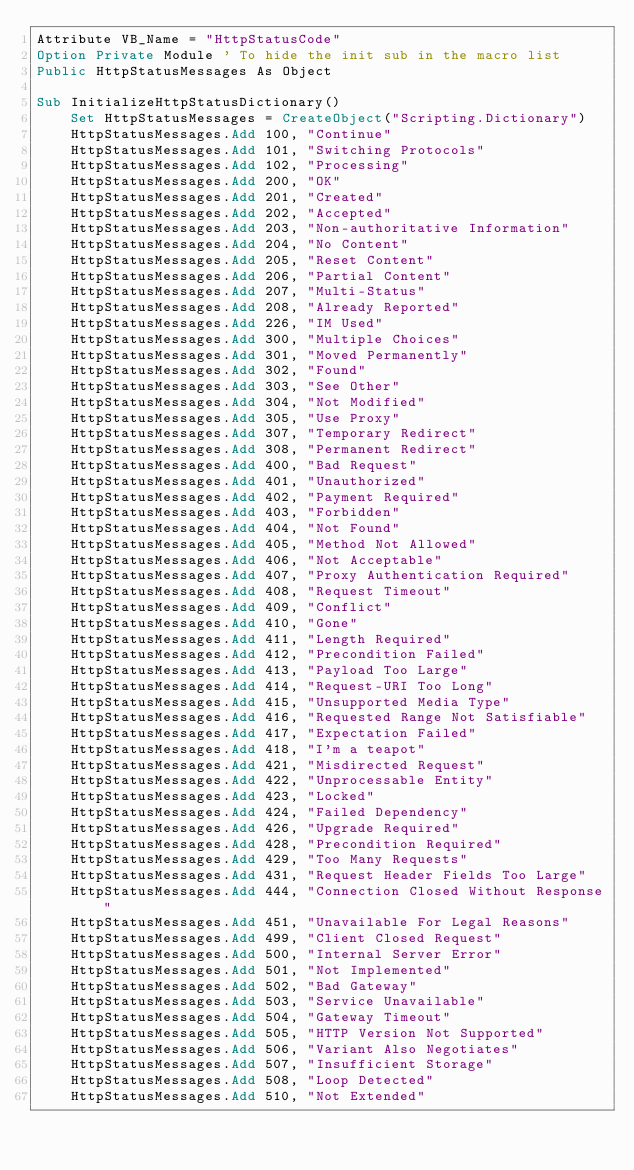Convert code to text. <code><loc_0><loc_0><loc_500><loc_500><_VisualBasic_>Attribute VB_Name = "HttpStatusCode"
Option Private Module ' To hide the init sub in the macro list
Public HttpStatusMessages As Object

Sub InitializeHttpStatusDictionary()
    Set HttpStatusMessages = CreateObject("Scripting.Dictionary")
    HttpStatusMessages.Add 100, "Continue"
    HttpStatusMessages.Add 101, "Switching Protocols"
    HttpStatusMessages.Add 102, "Processing"
    HttpStatusMessages.Add 200, "OK"
    HttpStatusMessages.Add 201, "Created"
    HttpStatusMessages.Add 202, "Accepted"
    HttpStatusMessages.Add 203, "Non-authoritative Information"
    HttpStatusMessages.Add 204, "No Content"
    HttpStatusMessages.Add 205, "Reset Content"
    HttpStatusMessages.Add 206, "Partial Content"
    HttpStatusMessages.Add 207, "Multi-Status"
    HttpStatusMessages.Add 208, "Already Reported"
    HttpStatusMessages.Add 226, "IM Used"
    HttpStatusMessages.Add 300, "Multiple Choices"
    HttpStatusMessages.Add 301, "Moved Permanently"
    HttpStatusMessages.Add 302, "Found"
    HttpStatusMessages.Add 303, "See Other"
    HttpStatusMessages.Add 304, "Not Modified"
    HttpStatusMessages.Add 305, "Use Proxy"
    HttpStatusMessages.Add 307, "Temporary Redirect"
    HttpStatusMessages.Add 308, "Permanent Redirect"
    HttpStatusMessages.Add 400, "Bad Request"
    HttpStatusMessages.Add 401, "Unauthorized"
    HttpStatusMessages.Add 402, "Payment Required"
    HttpStatusMessages.Add 403, "Forbidden"
    HttpStatusMessages.Add 404, "Not Found"
    HttpStatusMessages.Add 405, "Method Not Allowed"
    HttpStatusMessages.Add 406, "Not Acceptable"
    HttpStatusMessages.Add 407, "Proxy Authentication Required"
    HttpStatusMessages.Add 408, "Request Timeout"
    HttpStatusMessages.Add 409, "Conflict"
    HttpStatusMessages.Add 410, "Gone"
    HttpStatusMessages.Add 411, "Length Required"
    HttpStatusMessages.Add 412, "Precondition Failed"
    HttpStatusMessages.Add 413, "Payload Too Large"
    HttpStatusMessages.Add 414, "Request-URI Too Long"
    HttpStatusMessages.Add 415, "Unsupported Media Type"
    HttpStatusMessages.Add 416, "Requested Range Not Satisfiable"
    HttpStatusMessages.Add 417, "Expectation Failed"
    HttpStatusMessages.Add 418, "I'm a teapot"
    HttpStatusMessages.Add 421, "Misdirected Request"
    HttpStatusMessages.Add 422, "Unprocessable Entity"
    HttpStatusMessages.Add 423, "Locked"
    HttpStatusMessages.Add 424, "Failed Dependency"
    HttpStatusMessages.Add 426, "Upgrade Required"
    HttpStatusMessages.Add 428, "Precondition Required"
    HttpStatusMessages.Add 429, "Too Many Requests"
    HttpStatusMessages.Add 431, "Request Header Fields Too Large"
    HttpStatusMessages.Add 444, "Connection Closed Without Response"
    HttpStatusMessages.Add 451, "Unavailable For Legal Reasons"
    HttpStatusMessages.Add 499, "Client Closed Request"
    HttpStatusMessages.Add 500, "Internal Server Error"
    HttpStatusMessages.Add 501, "Not Implemented"
    HttpStatusMessages.Add 502, "Bad Gateway"
    HttpStatusMessages.Add 503, "Service Unavailable"
    HttpStatusMessages.Add 504, "Gateway Timeout"
    HttpStatusMessages.Add 505, "HTTP Version Not Supported"
    HttpStatusMessages.Add 506, "Variant Also Negotiates"
    HttpStatusMessages.Add 507, "Insufficient Storage"
    HttpStatusMessages.Add 508, "Loop Detected"
    HttpStatusMessages.Add 510, "Not Extended"</code> 